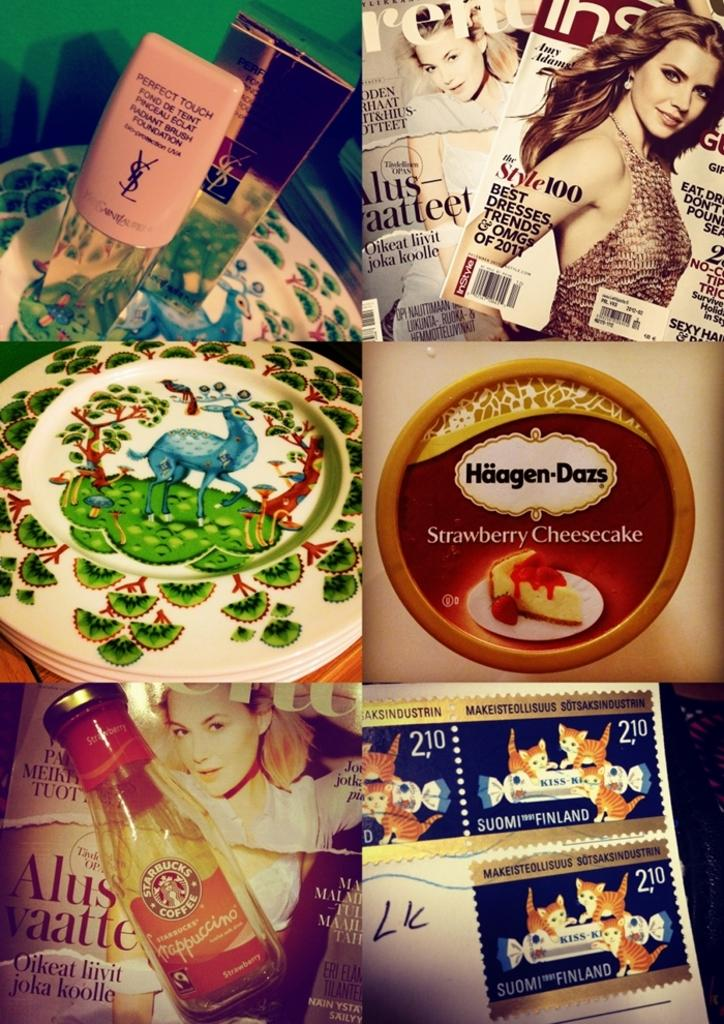Provide a one-sentence caption for the provided image. Montage of different things with some Haagen Dazs ice cream on the middle right. 